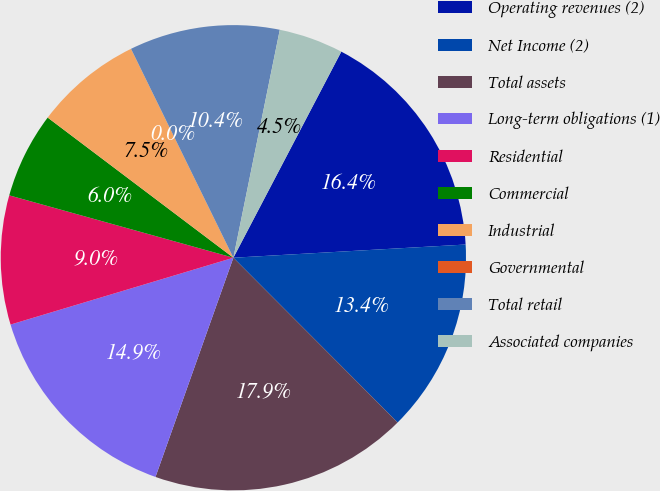Convert chart. <chart><loc_0><loc_0><loc_500><loc_500><pie_chart><fcel>Operating revenues (2)<fcel>Net Income (2)<fcel>Total assets<fcel>Long-term obligations (1)<fcel>Residential<fcel>Commercial<fcel>Industrial<fcel>Governmental<fcel>Total retail<fcel>Associated companies<nl><fcel>16.42%<fcel>13.43%<fcel>17.91%<fcel>14.93%<fcel>8.96%<fcel>5.97%<fcel>7.46%<fcel>0.0%<fcel>10.45%<fcel>4.48%<nl></chart> 